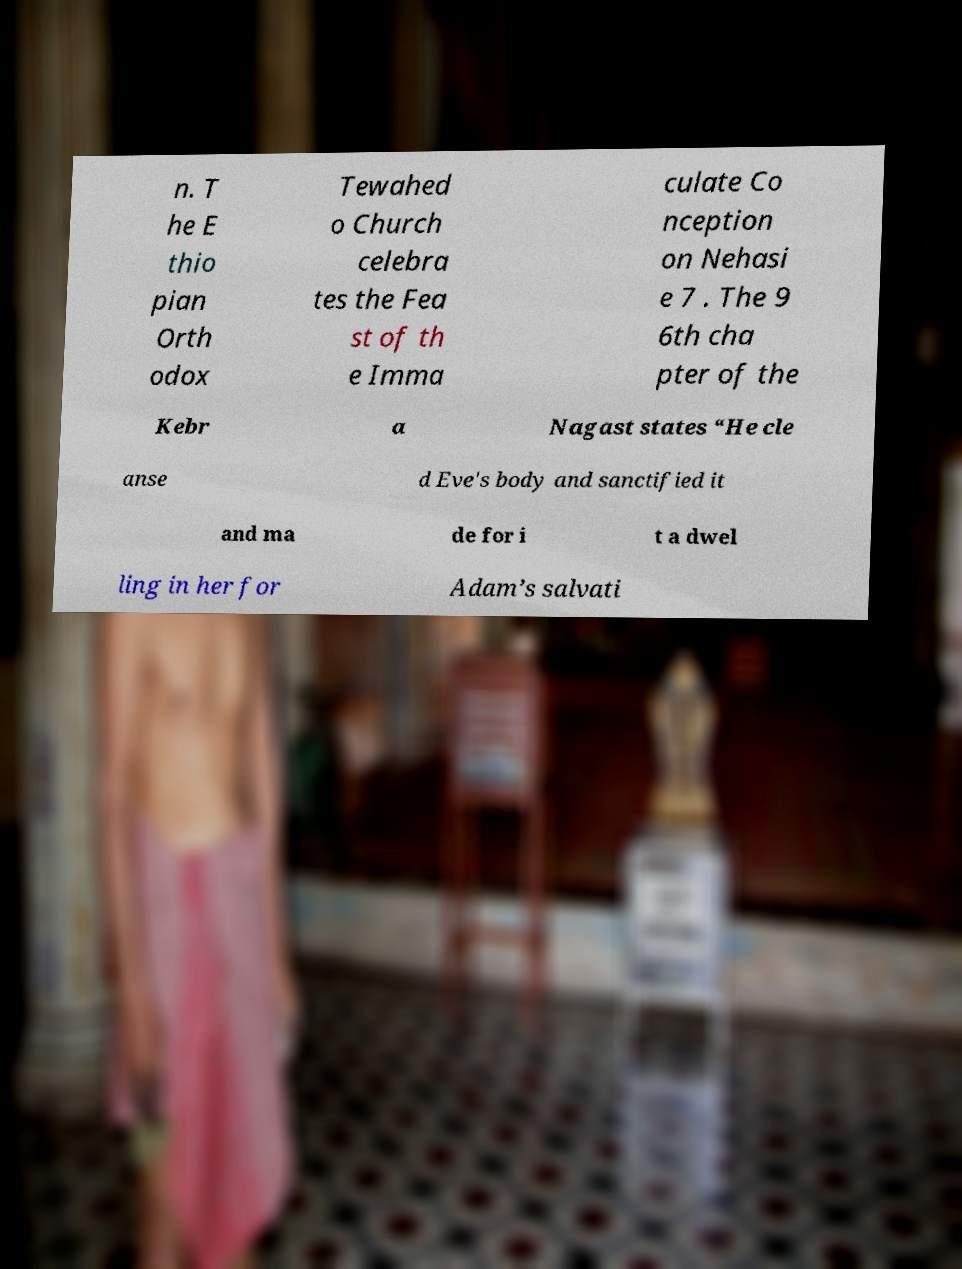Can you accurately transcribe the text from the provided image for me? n. T he E thio pian Orth odox Tewahed o Church celebra tes the Fea st of th e Imma culate Co nception on Nehasi e 7 . The 9 6th cha pter of the Kebr a Nagast states “He cle anse d Eve's body and sanctified it and ma de for i t a dwel ling in her for Adam’s salvati 